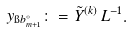Convert formula to latex. <formula><loc_0><loc_0><loc_500><loc_500>y _ { \i b _ { m + 1 } ^ { \circ } } \colon = \tilde { Y } ^ { ( k ) } \, L ^ { - 1 } .</formula> 